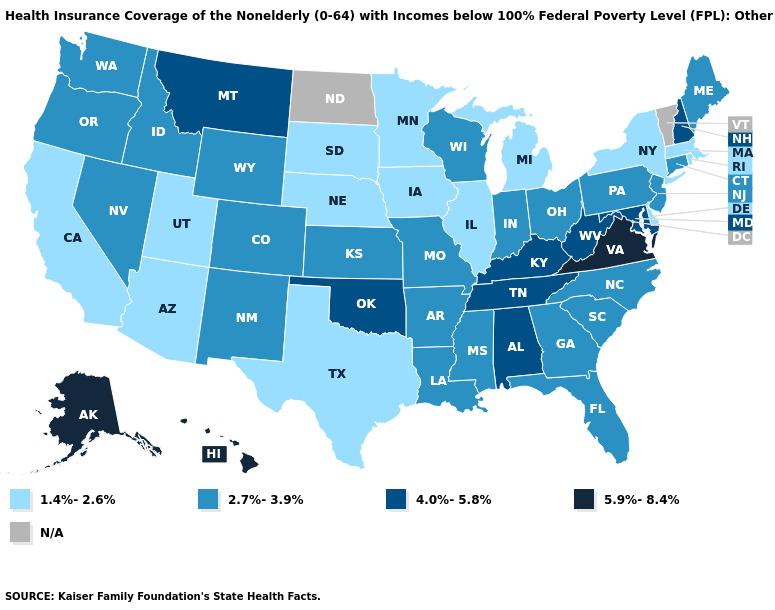Which states have the highest value in the USA?
Give a very brief answer. Alaska, Hawaii, Virginia. What is the value of Minnesota?
Answer briefly. 1.4%-2.6%. What is the value of New Hampshire?
Quick response, please. 4.0%-5.8%. What is the value of Alaska?
Short answer required. 5.9%-8.4%. Does Illinois have the highest value in the MidWest?
Write a very short answer. No. What is the highest value in the Northeast ?
Give a very brief answer. 4.0%-5.8%. Name the states that have a value in the range 1.4%-2.6%?
Keep it brief. Arizona, California, Delaware, Illinois, Iowa, Massachusetts, Michigan, Minnesota, Nebraska, New York, Rhode Island, South Dakota, Texas, Utah. Name the states that have a value in the range 1.4%-2.6%?
Write a very short answer. Arizona, California, Delaware, Illinois, Iowa, Massachusetts, Michigan, Minnesota, Nebraska, New York, Rhode Island, South Dakota, Texas, Utah. Does the map have missing data?
Give a very brief answer. Yes. What is the value of Arkansas?
Quick response, please. 2.7%-3.9%. What is the value of Colorado?
Concise answer only. 2.7%-3.9%. Which states have the lowest value in the West?
Be succinct. Arizona, California, Utah. What is the value of Pennsylvania?
Write a very short answer. 2.7%-3.9%. 